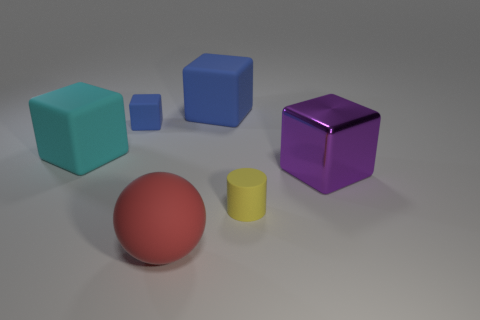Subtract all brown blocks. Subtract all cyan cylinders. How many blocks are left? 4 Add 1 red rubber objects. How many objects exist? 7 Subtract all balls. How many objects are left? 5 Add 2 tiny blue matte cubes. How many tiny blue matte cubes are left? 3 Add 4 large metal blocks. How many large metal blocks exist? 5 Subtract 2 blue blocks. How many objects are left? 4 Subtract all small cylinders. Subtract all shiny objects. How many objects are left? 4 